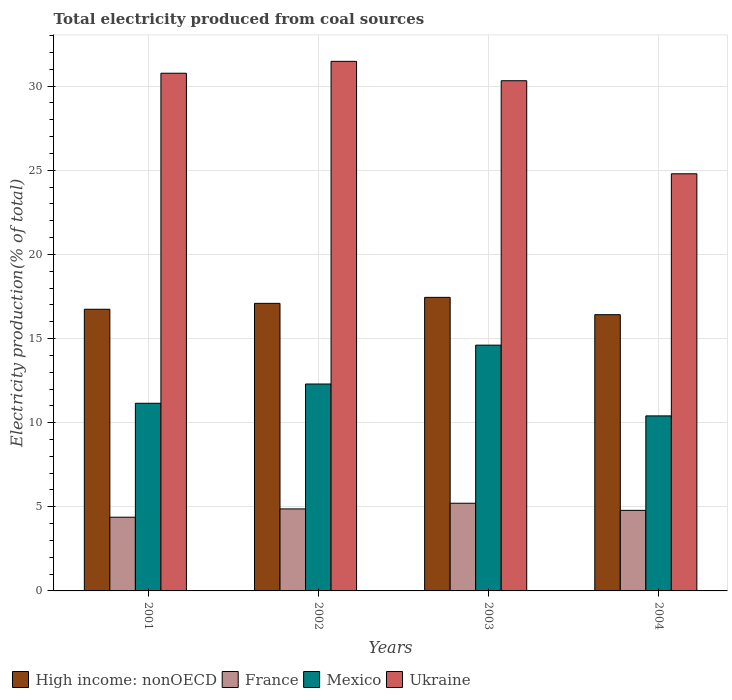What is the label of the 1st group of bars from the left?
Your answer should be compact. 2001. In how many cases, is the number of bars for a given year not equal to the number of legend labels?
Offer a very short reply. 0. What is the total electricity produced in France in 2004?
Your answer should be compact. 4.79. Across all years, what is the maximum total electricity produced in Mexico?
Give a very brief answer. 14.61. Across all years, what is the minimum total electricity produced in High income: nonOECD?
Give a very brief answer. 16.42. In which year was the total electricity produced in High income: nonOECD maximum?
Offer a very short reply. 2003. What is the total total electricity produced in High income: nonOECD in the graph?
Ensure brevity in your answer.  67.69. What is the difference between the total electricity produced in High income: nonOECD in 2001 and that in 2004?
Your answer should be very brief. 0.32. What is the difference between the total electricity produced in France in 2001 and the total electricity produced in Ukraine in 2004?
Provide a succinct answer. -20.41. What is the average total electricity produced in France per year?
Keep it short and to the point. 4.81. In the year 2002, what is the difference between the total electricity produced in France and total electricity produced in Mexico?
Ensure brevity in your answer.  -7.42. In how many years, is the total electricity produced in Mexico greater than 25 %?
Provide a succinct answer. 0. What is the ratio of the total electricity produced in Ukraine in 2002 to that in 2004?
Your response must be concise. 1.27. Is the total electricity produced in Ukraine in 2001 less than that in 2003?
Ensure brevity in your answer.  No. What is the difference between the highest and the second highest total electricity produced in France?
Offer a very short reply. 0.34. What is the difference between the highest and the lowest total electricity produced in France?
Your response must be concise. 0.83. In how many years, is the total electricity produced in France greater than the average total electricity produced in France taken over all years?
Keep it short and to the point. 2. Is it the case that in every year, the sum of the total electricity produced in Mexico and total electricity produced in Ukraine is greater than the sum of total electricity produced in France and total electricity produced in High income: nonOECD?
Your response must be concise. Yes. What does the 1st bar from the left in 2003 represents?
Your answer should be compact. High income: nonOECD. What does the 4th bar from the right in 2002 represents?
Ensure brevity in your answer.  High income: nonOECD. Is it the case that in every year, the sum of the total electricity produced in High income: nonOECD and total electricity produced in Ukraine is greater than the total electricity produced in France?
Offer a terse response. Yes. How many bars are there?
Offer a terse response. 16. How many years are there in the graph?
Your answer should be compact. 4. What is the difference between two consecutive major ticks on the Y-axis?
Your answer should be very brief. 5. Does the graph contain any zero values?
Provide a short and direct response. No. Does the graph contain grids?
Your answer should be very brief. Yes. Where does the legend appear in the graph?
Give a very brief answer. Bottom left. How are the legend labels stacked?
Offer a very short reply. Horizontal. What is the title of the graph?
Make the answer very short. Total electricity produced from coal sources. Does "Caribbean small states" appear as one of the legend labels in the graph?
Keep it short and to the point. No. What is the label or title of the X-axis?
Make the answer very short. Years. What is the Electricity production(% of total) in High income: nonOECD in 2001?
Provide a short and direct response. 16.74. What is the Electricity production(% of total) in France in 2001?
Ensure brevity in your answer.  4.38. What is the Electricity production(% of total) of Mexico in 2001?
Provide a succinct answer. 11.15. What is the Electricity production(% of total) in Ukraine in 2001?
Provide a short and direct response. 30.77. What is the Electricity production(% of total) of High income: nonOECD in 2002?
Provide a short and direct response. 17.09. What is the Electricity production(% of total) of France in 2002?
Your response must be concise. 4.87. What is the Electricity production(% of total) in Mexico in 2002?
Ensure brevity in your answer.  12.3. What is the Electricity production(% of total) in Ukraine in 2002?
Ensure brevity in your answer.  31.47. What is the Electricity production(% of total) in High income: nonOECD in 2003?
Your answer should be very brief. 17.45. What is the Electricity production(% of total) in France in 2003?
Give a very brief answer. 5.21. What is the Electricity production(% of total) in Mexico in 2003?
Keep it short and to the point. 14.61. What is the Electricity production(% of total) of Ukraine in 2003?
Keep it short and to the point. 30.32. What is the Electricity production(% of total) of High income: nonOECD in 2004?
Provide a succinct answer. 16.42. What is the Electricity production(% of total) in France in 2004?
Your answer should be very brief. 4.79. What is the Electricity production(% of total) in Mexico in 2004?
Your response must be concise. 10.4. What is the Electricity production(% of total) in Ukraine in 2004?
Your answer should be very brief. 24.79. Across all years, what is the maximum Electricity production(% of total) of High income: nonOECD?
Make the answer very short. 17.45. Across all years, what is the maximum Electricity production(% of total) of France?
Ensure brevity in your answer.  5.21. Across all years, what is the maximum Electricity production(% of total) in Mexico?
Provide a succinct answer. 14.61. Across all years, what is the maximum Electricity production(% of total) in Ukraine?
Make the answer very short. 31.47. Across all years, what is the minimum Electricity production(% of total) of High income: nonOECD?
Offer a very short reply. 16.42. Across all years, what is the minimum Electricity production(% of total) of France?
Your response must be concise. 4.38. Across all years, what is the minimum Electricity production(% of total) of Mexico?
Ensure brevity in your answer.  10.4. Across all years, what is the minimum Electricity production(% of total) in Ukraine?
Ensure brevity in your answer.  24.79. What is the total Electricity production(% of total) in High income: nonOECD in the graph?
Provide a short and direct response. 67.69. What is the total Electricity production(% of total) in France in the graph?
Offer a very short reply. 19.25. What is the total Electricity production(% of total) of Mexico in the graph?
Offer a terse response. 48.46. What is the total Electricity production(% of total) in Ukraine in the graph?
Your response must be concise. 117.36. What is the difference between the Electricity production(% of total) in High income: nonOECD in 2001 and that in 2002?
Your response must be concise. -0.35. What is the difference between the Electricity production(% of total) of France in 2001 and that in 2002?
Offer a very short reply. -0.49. What is the difference between the Electricity production(% of total) in Mexico in 2001 and that in 2002?
Give a very brief answer. -1.14. What is the difference between the Electricity production(% of total) of Ukraine in 2001 and that in 2002?
Keep it short and to the point. -0.71. What is the difference between the Electricity production(% of total) of High income: nonOECD in 2001 and that in 2003?
Give a very brief answer. -0.71. What is the difference between the Electricity production(% of total) of France in 2001 and that in 2003?
Offer a very short reply. -0.83. What is the difference between the Electricity production(% of total) in Mexico in 2001 and that in 2003?
Provide a succinct answer. -3.45. What is the difference between the Electricity production(% of total) in Ukraine in 2001 and that in 2003?
Offer a terse response. 0.45. What is the difference between the Electricity production(% of total) of High income: nonOECD in 2001 and that in 2004?
Ensure brevity in your answer.  0.32. What is the difference between the Electricity production(% of total) in France in 2001 and that in 2004?
Offer a very short reply. -0.41. What is the difference between the Electricity production(% of total) in Mexico in 2001 and that in 2004?
Offer a terse response. 0.75. What is the difference between the Electricity production(% of total) in Ukraine in 2001 and that in 2004?
Your answer should be compact. 5.98. What is the difference between the Electricity production(% of total) in High income: nonOECD in 2002 and that in 2003?
Keep it short and to the point. -0.36. What is the difference between the Electricity production(% of total) in France in 2002 and that in 2003?
Keep it short and to the point. -0.34. What is the difference between the Electricity production(% of total) of Mexico in 2002 and that in 2003?
Offer a very short reply. -2.31. What is the difference between the Electricity production(% of total) of Ukraine in 2002 and that in 2003?
Provide a short and direct response. 1.15. What is the difference between the Electricity production(% of total) in High income: nonOECD in 2002 and that in 2004?
Offer a terse response. 0.67. What is the difference between the Electricity production(% of total) of France in 2002 and that in 2004?
Provide a succinct answer. 0.09. What is the difference between the Electricity production(% of total) in Mexico in 2002 and that in 2004?
Offer a terse response. 1.89. What is the difference between the Electricity production(% of total) in Ukraine in 2002 and that in 2004?
Your answer should be very brief. 6.68. What is the difference between the Electricity production(% of total) in France in 2003 and that in 2004?
Offer a terse response. 0.42. What is the difference between the Electricity production(% of total) of Mexico in 2003 and that in 2004?
Keep it short and to the point. 4.2. What is the difference between the Electricity production(% of total) of Ukraine in 2003 and that in 2004?
Keep it short and to the point. 5.53. What is the difference between the Electricity production(% of total) in High income: nonOECD in 2001 and the Electricity production(% of total) in France in 2002?
Ensure brevity in your answer.  11.87. What is the difference between the Electricity production(% of total) of High income: nonOECD in 2001 and the Electricity production(% of total) of Mexico in 2002?
Your answer should be very brief. 4.44. What is the difference between the Electricity production(% of total) of High income: nonOECD in 2001 and the Electricity production(% of total) of Ukraine in 2002?
Make the answer very short. -14.73. What is the difference between the Electricity production(% of total) of France in 2001 and the Electricity production(% of total) of Mexico in 2002?
Your answer should be compact. -7.92. What is the difference between the Electricity production(% of total) of France in 2001 and the Electricity production(% of total) of Ukraine in 2002?
Your answer should be compact. -27.09. What is the difference between the Electricity production(% of total) of Mexico in 2001 and the Electricity production(% of total) of Ukraine in 2002?
Offer a very short reply. -20.32. What is the difference between the Electricity production(% of total) in High income: nonOECD in 2001 and the Electricity production(% of total) in France in 2003?
Offer a terse response. 11.53. What is the difference between the Electricity production(% of total) in High income: nonOECD in 2001 and the Electricity production(% of total) in Mexico in 2003?
Make the answer very short. 2.13. What is the difference between the Electricity production(% of total) of High income: nonOECD in 2001 and the Electricity production(% of total) of Ukraine in 2003?
Provide a succinct answer. -13.58. What is the difference between the Electricity production(% of total) of France in 2001 and the Electricity production(% of total) of Mexico in 2003?
Give a very brief answer. -10.23. What is the difference between the Electricity production(% of total) of France in 2001 and the Electricity production(% of total) of Ukraine in 2003?
Your answer should be very brief. -25.94. What is the difference between the Electricity production(% of total) of Mexico in 2001 and the Electricity production(% of total) of Ukraine in 2003?
Give a very brief answer. -19.17. What is the difference between the Electricity production(% of total) in High income: nonOECD in 2001 and the Electricity production(% of total) in France in 2004?
Keep it short and to the point. 11.95. What is the difference between the Electricity production(% of total) in High income: nonOECD in 2001 and the Electricity production(% of total) in Mexico in 2004?
Ensure brevity in your answer.  6.34. What is the difference between the Electricity production(% of total) of High income: nonOECD in 2001 and the Electricity production(% of total) of Ukraine in 2004?
Give a very brief answer. -8.05. What is the difference between the Electricity production(% of total) in France in 2001 and the Electricity production(% of total) in Mexico in 2004?
Ensure brevity in your answer.  -6.02. What is the difference between the Electricity production(% of total) of France in 2001 and the Electricity production(% of total) of Ukraine in 2004?
Make the answer very short. -20.41. What is the difference between the Electricity production(% of total) of Mexico in 2001 and the Electricity production(% of total) of Ukraine in 2004?
Keep it short and to the point. -13.64. What is the difference between the Electricity production(% of total) in High income: nonOECD in 2002 and the Electricity production(% of total) in France in 2003?
Provide a short and direct response. 11.88. What is the difference between the Electricity production(% of total) in High income: nonOECD in 2002 and the Electricity production(% of total) in Mexico in 2003?
Your response must be concise. 2.48. What is the difference between the Electricity production(% of total) in High income: nonOECD in 2002 and the Electricity production(% of total) in Ukraine in 2003?
Offer a very short reply. -13.23. What is the difference between the Electricity production(% of total) of France in 2002 and the Electricity production(% of total) of Mexico in 2003?
Offer a terse response. -9.73. What is the difference between the Electricity production(% of total) of France in 2002 and the Electricity production(% of total) of Ukraine in 2003?
Provide a succinct answer. -25.45. What is the difference between the Electricity production(% of total) in Mexico in 2002 and the Electricity production(% of total) in Ukraine in 2003?
Provide a succinct answer. -18.03. What is the difference between the Electricity production(% of total) of High income: nonOECD in 2002 and the Electricity production(% of total) of France in 2004?
Offer a very short reply. 12.3. What is the difference between the Electricity production(% of total) in High income: nonOECD in 2002 and the Electricity production(% of total) in Mexico in 2004?
Provide a short and direct response. 6.69. What is the difference between the Electricity production(% of total) in High income: nonOECD in 2002 and the Electricity production(% of total) in Ukraine in 2004?
Give a very brief answer. -7.7. What is the difference between the Electricity production(% of total) of France in 2002 and the Electricity production(% of total) of Mexico in 2004?
Ensure brevity in your answer.  -5.53. What is the difference between the Electricity production(% of total) in France in 2002 and the Electricity production(% of total) in Ukraine in 2004?
Your answer should be compact. -19.92. What is the difference between the Electricity production(% of total) of Mexico in 2002 and the Electricity production(% of total) of Ukraine in 2004?
Offer a terse response. -12.49. What is the difference between the Electricity production(% of total) of High income: nonOECD in 2003 and the Electricity production(% of total) of France in 2004?
Provide a succinct answer. 12.66. What is the difference between the Electricity production(% of total) in High income: nonOECD in 2003 and the Electricity production(% of total) in Mexico in 2004?
Provide a short and direct response. 7.04. What is the difference between the Electricity production(% of total) in High income: nonOECD in 2003 and the Electricity production(% of total) in Ukraine in 2004?
Offer a very short reply. -7.35. What is the difference between the Electricity production(% of total) in France in 2003 and the Electricity production(% of total) in Mexico in 2004?
Make the answer very short. -5.19. What is the difference between the Electricity production(% of total) in France in 2003 and the Electricity production(% of total) in Ukraine in 2004?
Your response must be concise. -19.58. What is the difference between the Electricity production(% of total) in Mexico in 2003 and the Electricity production(% of total) in Ukraine in 2004?
Your answer should be compact. -10.19. What is the average Electricity production(% of total) in High income: nonOECD per year?
Your answer should be compact. 16.92. What is the average Electricity production(% of total) in France per year?
Provide a succinct answer. 4.81. What is the average Electricity production(% of total) of Mexico per year?
Give a very brief answer. 12.11. What is the average Electricity production(% of total) in Ukraine per year?
Offer a terse response. 29.34. In the year 2001, what is the difference between the Electricity production(% of total) of High income: nonOECD and Electricity production(% of total) of France?
Offer a very short reply. 12.36. In the year 2001, what is the difference between the Electricity production(% of total) of High income: nonOECD and Electricity production(% of total) of Mexico?
Give a very brief answer. 5.59. In the year 2001, what is the difference between the Electricity production(% of total) of High income: nonOECD and Electricity production(% of total) of Ukraine?
Offer a terse response. -14.03. In the year 2001, what is the difference between the Electricity production(% of total) of France and Electricity production(% of total) of Mexico?
Offer a terse response. -6.77. In the year 2001, what is the difference between the Electricity production(% of total) of France and Electricity production(% of total) of Ukraine?
Your answer should be compact. -26.39. In the year 2001, what is the difference between the Electricity production(% of total) of Mexico and Electricity production(% of total) of Ukraine?
Your response must be concise. -19.62. In the year 2002, what is the difference between the Electricity production(% of total) in High income: nonOECD and Electricity production(% of total) in France?
Your answer should be compact. 12.22. In the year 2002, what is the difference between the Electricity production(% of total) of High income: nonOECD and Electricity production(% of total) of Mexico?
Keep it short and to the point. 4.79. In the year 2002, what is the difference between the Electricity production(% of total) in High income: nonOECD and Electricity production(% of total) in Ukraine?
Offer a very short reply. -14.38. In the year 2002, what is the difference between the Electricity production(% of total) of France and Electricity production(% of total) of Mexico?
Provide a succinct answer. -7.42. In the year 2002, what is the difference between the Electricity production(% of total) of France and Electricity production(% of total) of Ukraine?
Give a very brief answer. -26.6. In the year 2002, what is the difference between the Electricity production(% of total) in Mexico and Electricity production(% of total) in Ukraine?
Your answer should be very brief. -19.18. In the year 2003, what is the difference between the Electricity production(% of total) in High income: nonOECD and Electricity production(% of total) in France?
Offer a very short reply. 12.23. In the year 2003, what is the difference between the Electricity production(% of total) of High income: nonOECD and Electricity production(% of total) of Mexico?
Offer a very short reply. 2.84. In the year 2003, what is the difference between the Electricity production(% of total) in High income: nonOECD and Electricity production(% of total) in Ukraine?
Your response must be concise. -12.88. In the year 2003, what is the difference between the Electricity production(% of total) of France and Electricity production(% of total) of Mexico?
Provide a succinct answer. -9.4. In the year 2003, what is the difference between the Electricity production(% of total) in France and Electricity production(% of total) in Ukraine?
Give a very brief answer. -25.11. In the year 2003, what is the difference between the Electricity production(% of total) in Mexico and Electricity production(% of total) in Ukraine?
Offer a terse response. -15.72. In the year 2004, what is the difference between the Electricity production(% of total) of High income: nonOECD and Electricity production(% of total) of France?
Provide a succinct answer. 11.63. In the year 2004, what is the difference between the Electricity production(% of total) in High income: nonOECD and Electricity production(% of total) in Mexico?
Your answer should be compact. 6.02. In the year 2004, what is the difference between the Electricity production(% of total) in High income: nonOECD and Electricity production(% of total) in Ukraine?
Provide a short and direct response. -8.37. In the year 2004, what is the difference between the Electricity production(% of total) of France and Electricity production(% of total) of Mexico?
Your response must be concise. -5.62. In the year 2004, what is the difference between the Electricity production(% of total) of France and Electricity production(% of total) of Ukraine?
Your response must be concise. -20. In the year 2004, what is the difference between the Electricity production(% of total) of Mexico and Electricity production(% of total) of Ukraine?
Keep it short and to the point. -14.39. What is the ratio of the Electricity production(% of total) in High income: nonOECD in 2001 to that in 2002?
Your response must be concise. 0.98. What is the ratio of the Electricity production(% of total) in France in 2001 to that in 2002?
Keep it short and to the point. 0.9. What is the ratio of the Electricity production(% of total) in Mexico in 2001 to that in 2002?
Your response must be concise. 0.91. What is the ratio of the Electricity production(% of total) of Ukraine in 2001 to that in 2002?
Your answer should be compact. 0.98. What is the ratio of the Electricity production(% of total) in High income: nonOECD in 2001 to that in 2003?
Offer a very short reply. 0.96. What is the ratio of the Electricity production(% of total) of France in 2001 to that in 2003?
Ensure brevity in your answer.  0.84. What is the ratio of the Electricity production(% of total) in Mexico in 2001 to that in 2003?
Give a very brief answer. 0.76. What is the ratio of the Electricity production(% of total) of Ukraine in 2001 to that in 2003?
Your response must be concise. 1.01. What is the ratio of the Electricity production(% of total) of High income: nonOECD in 2001 to that in 2004?
Provide a short and direct response. 1.02. What is the ratio of the Electricity production(% of total) of France in 2001 to that in 2004?
Keep it short and to the point. 0.92. What is the ratio of the Electricity production(% of total) of Mexico in 2001 to that in 2004?
Your answer should be very brief. 1.07. What is the ratio of the Electricity production(% of total) of Ukraine in 2001 to that in 2004?
Ensure brevity in your answer.  1.24. What is the ratio of the Electricity production(% of total) of High income: nonOECD in 2002 to that in 2003?
Your answer should be compact. 0.98. What is the ratio of the Electricity production(% of total) of France in 2002 to that in 2003?
Keep it short and to the point. 0.94. What is the ratio of the Electricity production(% of total) of Mexico in 2002 to that in 2003?
Provide a short and direct response. 0.84. What is the ratio of the Electricity production(% of total) of Ukraine in 2002 to that in 2003?
Ensure brevity in your answer.  1.04. What is the ratio of the Electricity production(% of total) of High income: nonOECD in 2002 to that in 2004?
Keep it short and to the point. 1.04. What is the ratio of the Electricity production(% of total) of France in 2002 to that in 2004?
Your response must be concise. 1.02. What is the ratio of the Electricity production(% of total) in Mexico in 2002 to that in 2004?
Your answer should be compact. 1.18. What is the ratio of the Electricity production(% of total) in Ukraine in 2002 to that in 2004?
Offer a very short reply. 1.27. What is the ratio of the Electricity production(% of total) of High income: nonOECD in 2003 to that in 2004?
Provide a short and direct response. 1.06. What is the ratio of the Electricity production(% of total) in France in 2003 to that in 2004?
Offer a terse response. 1.09. What is the ratio of the Electricity production(% of total) in Mexico in 2003 to that in 2004?
Keep it short and to the point. 1.4. What is the ratio of the Electricity production(% of total) of Ukraine in 2003 to that in 2004?
Offer a terse response. 1.22. What is the difference between the highest and the second highest Electricity production(% of total) of High income: nonOECD?
Offer a very short reply. 0.36. What is the difference between the highest and the second highest Electricity production(% of total) in France?
Ensure brevity in your answer.  0.34. What is the difference between the highest and the second highest Electricity production(% of total) of Mexico?
Your answer should be compact. 2.31. What is the difference between the highest and the second highest Electricity production(% of total) in Ukraine?
Your response must be concise. 0.71. What is the difference between the highest and the lowest Electricity production(% of total) in High income: nonOECD?
Give a very brief answer. 1.03. What is the difference between the highest and the lowest Electricity production(% of total) in France?
Keep it short and to the point. 0.83. What is the difference between the highest and the lowest Electricity production(% of total) in Mexico?
Provide a short and direct response. 4.2. What is the difference between the highest and the lowest Electricity production(% of total) in Ukraine?
Offer a terse response. 6.68. 